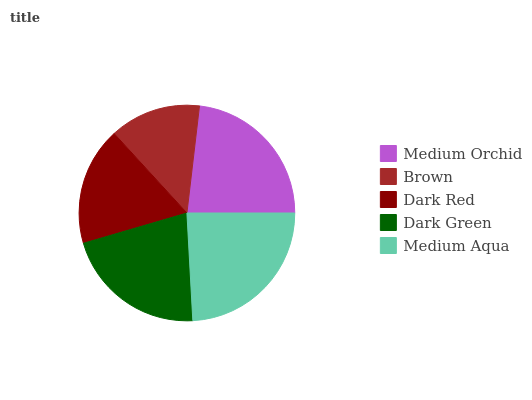Is Brown the minimum?
Answer yes or no. Yes. Is Medium Aqua the maximum?
Answer yes or no. Yes. Is Dark Red the minimum?
Answer yes or no. No. Is Dark Red the maximum?
Answer yes or no. No. Is Dark Red greater than Brown?
Answer yes or no. Yes. Is Brown less than Dark Red?
Answer yes or no. Yes. Is Brown greater than Dark Red?
Answer yes or no. No. Is Dark Red less than Brown?
Answer yes or no. No. Is Dark Green the high median?
Answer yes or no. Yes. Is Dark Green the low median?
Answer yes or no. Yes. Is Medium Aqua the high median?
Answer yes or no. No. Is Brown the low median?
Answer yes or no. No. 